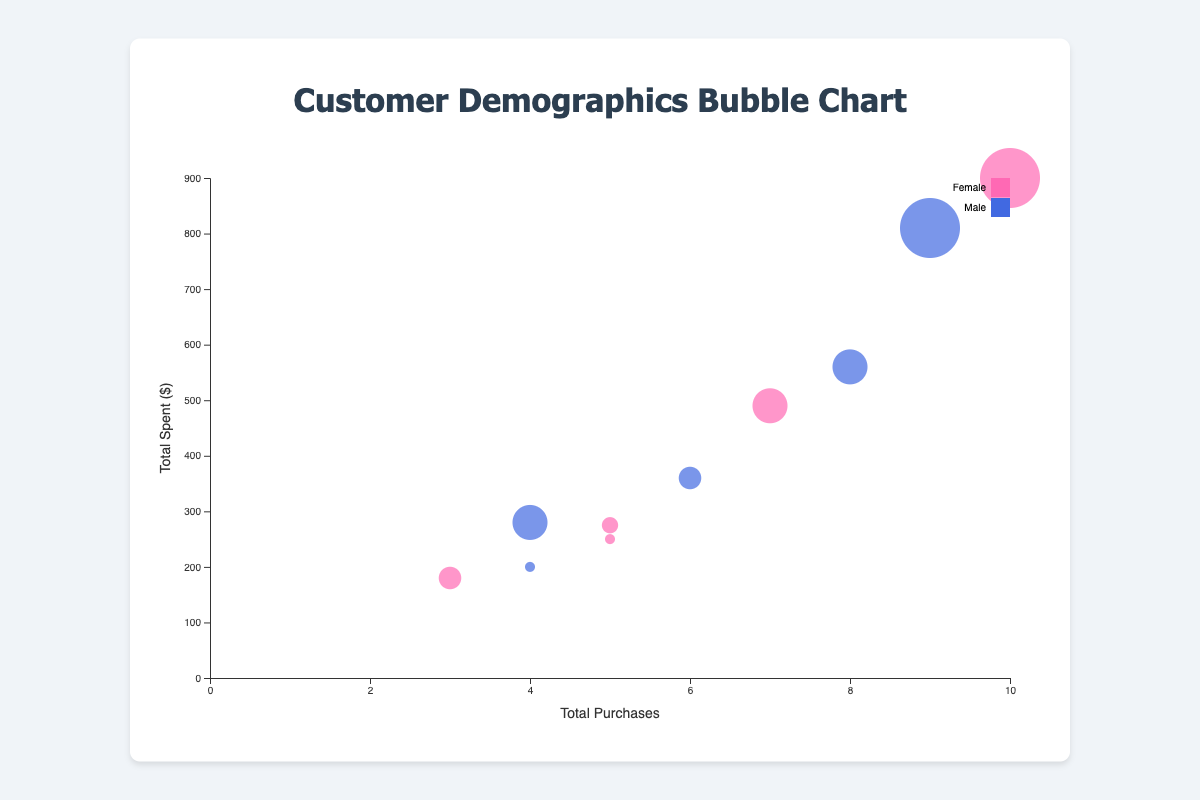What is the title of the bubble chart? The title is usually found at the top of the chart. In this case, it's labeled at the top of the chart in the center.
Answer: Customer Demographics Bubble Chart How many customers have a demographic labeled "Age 26-35, Female"? Identify the data points whose demographic matches "Age 26-35, Female". Only one data point fits this condition.
Answer: 1 Which customer has the highest number of total purchases, and how many purchases is that? Look for the data point with the highest value on the x-axis representing Total Purchases, which is 10 by CustomerId "CUST003".
Answer: CUST003, 10 What is the average transaction value for the customer with the maximum total spent? Identify the data point with the highest y-axis value for Total Spent, which corresponds to "CUST003" ($900). The average transaction value for this customer is shown.
Answer: 90 What are the colors used for male and female customers? The color legend will indicate which color corresponds to male and female. Females are shown with a pink (#FF69B4) color, and males with a blue (#4169E1) color.
Answer: Pink for Female, Blue for Male Which demographic group has more total spent, "Age 36-45, Male" or "Age 46-55, Female"? Compare the y-axis values for "CUST007" (Age 36-45, Male) and "CUST008" (Age 46-55, Female). "CUST007" has $810 spent, while "CUST008" has $275 spent.
Answer: Age 36-45, Male What is the sum of total purchases for all customers aged 18-25? Sum the Total Purchases for "CUST001" and "CUST005" where the demographic is "Age 18-25". (5 + 4) = 9.
Answer: 9 Which gender has a higher total average transaction value among all customers? Calculate the average transaction value for both genders. Females: (50 + 70 + 90 + 55 + 60) / 5 = 65; Males: (70 + 60 + 50 + 90 + 70) / 5 = 68.
Answer: Male Which customer has a total spent closest to $300, and what is their average transaction value? Compare Total Spent values to $300. "CUST008" has $275 as the closest value. Their average transaction value is $55.
Answer: CUST008, $55 What is the total number of distinct demographic groups in the data? Count unique demographic descriptions in the dataset. There are 5 distinct groups: "Age 18-25, Female", "Age 26-35, Male", "Age 36-45, Female", "Age 46-55, Male", "Age 56-65, Female".
Answer: 5 